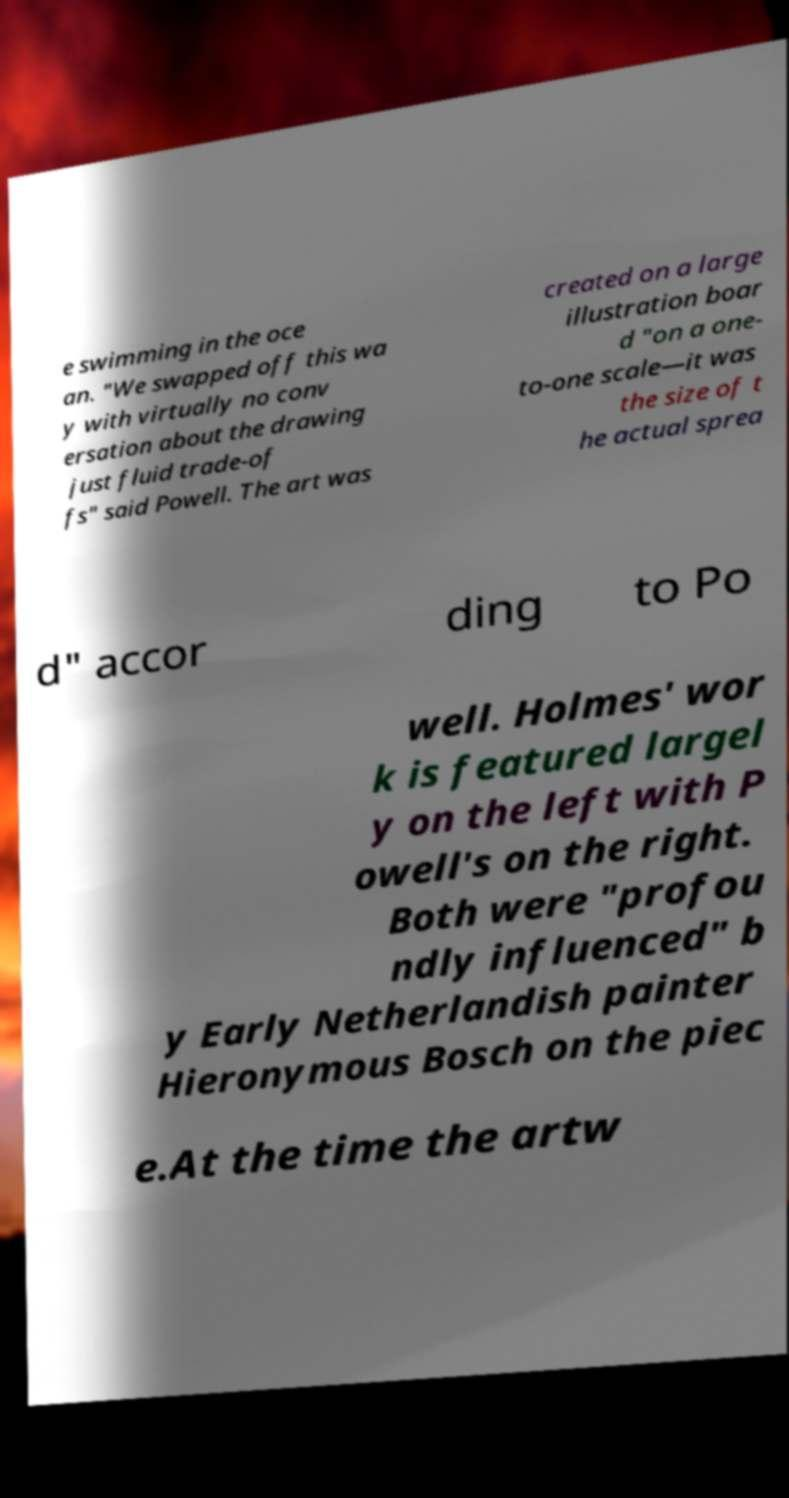For documentation purposes, I need the text within this image transcribed. Could you provide that? e swimming in the oce an. "We swapped off this wa y with virtually no conv ersation about the drawing just fluid trade-of fs" said Powell. The art was created on a large illustration boar d "on a one- to-one scale—it was the size of t he actual sprea d" accor ding to Po well. Holmes' wor k is featured largel y on the left with P owell's on the right. Both were "profou ndly influenced" b y Early Netherlandish painter Hieronymous Bosch on the piec e.At the time the artw 